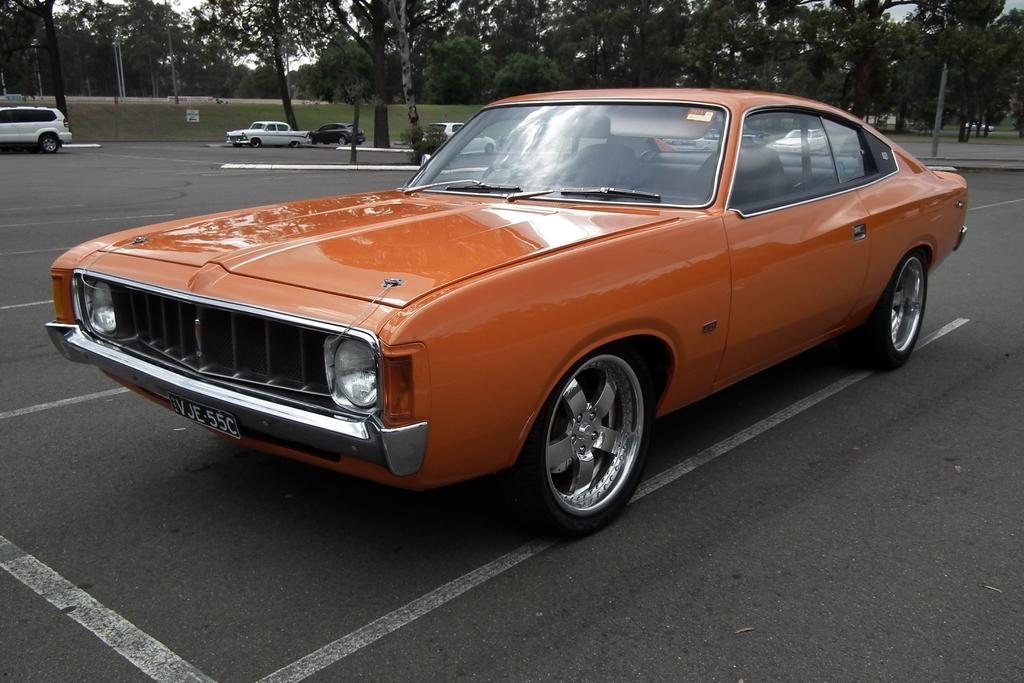What can be seen on the road in the image? There are cars on the road in the image. What type of vegetation is visible in the image? There is grass, plants, and trees visible in the image. What is the border made of in the image? The border's material is not specified in the facts, so we cannot determine its composition. What is visible in the background of the image? The sky is visible in the background of the image. How many flowers are present in the image? There is no mention of flowers in the image, so we cannot determine their presence or quantity. What shape is the square in the image? There is no square present in the image. 